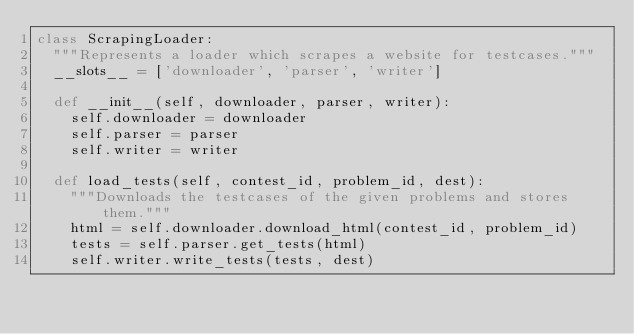Convert code to text. <code><loc_0><loc_0><loc_500><loc_500><_Python_>class ScrapingLoader:
  """Represents a loader which scrapes a website for testcases."""
  __slots__ = ['downloader', 'parser', 'writer']

  def __init__(self, downloader, parser, writer):
    self.downloader = downloader
    self.parser = parser
    self.writer = writer

  def load_tests(self, contest_id, problem_id, dest):
    """Downloads the testcases of the given problems and stores them."""
    html = self.downloader.download_html(contest_id, problem_id)
    tests = self.parser.get_tests(html)
    self.writer.write_tests(tests, dest)
</code> 